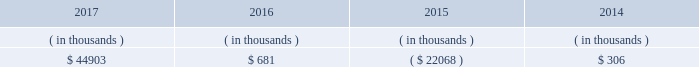All debt and common and preferred stock issuances by entergy texas require prior regulatory approval .
Debt issuances are also subject to issuance tests set forth in its bond indenture and other agreements .
Entergy texas has sufficient capacity under these tests to meet its foreseeable capital needs .
Entergy texas 2019s receivables from or ( payables to ) the money pool were as follows as of december 31 for each of the following years. .
See note 4 to the financial statements for a description of the money pool .
Entergy texas has a credit facility in the amount of $ 150 million scheduled to expire in august 2022 .
The credit facility allows entergy texas to issue letters of credit against $ 30 million of the borrowing capacity of the facility .
As of december 31 , 2017 , there were no cash borrowings and $ 25.6 million of letters of credit outstanding under the credit facility .
In addition , entergy texas is a party to an uncommitted letter of credit facility as a means to post collateral to support its obligations to miso .
As of december 31 , 2017 , a $ 22.8 million letter of credit was outstanding under entergy texas 2019s letter of credit facility .
See note 4 to the financial statements for additional discussion of the credit facilities .
Entergy texas obtained authorizations from the ferc through october 2019 for short-term borrowings , not to exceed an aggregate amount of $ 200 million at any time outstanding , and long-term borrowings and security issuances .
See note 4 to the financial statements for further discussion of entergy texas 2019s short-term borrowing limits .
Entergy texas , inc .
And subsidiaries management 2019s financial discussion and analysis state and local rate regulation and fuel-cost recovery the rates that entergy texas charges for its services significantly influence its financial position , results of operations , and liquidity .
Entergy texas is regulated and the rates charged to its customers are determined in regulatory proceedings .
The puct , a governmental agency , is primarily responsible for approval of the rates charged to customers .
Filings with the puct 2011 rate case in november 2011 , entergy texas filed a rate case requesting a $ 112 million base rate increase reflecting a 10.6% ( 10.6 % ) return on common equity based on an adjusted june 2011 test year . a0 a0the rate case also proposed a purchased power recovery rider . a0 a0on january 12 , 2012 , the puct voted not to address the purchased power recovery rider in the rate case , but the puct voted to set a baseline in the rate case proceeding that would be applicable if a purchased power capacity rider is approved in a separate proceeding . a0 a0in april 2012 the puct staff filed direct testimony recommending a base rate increase of $ 66 million and a 9.6% ( 9.6 % ) return on common equity . a0 a0the puct staff , however , subsequently filed a statement of position in the proceeding indicating that it was still evaluating the position it would ultimately take in the case regarding entergy texas 2019s recovery of purchased power capacity costs and entergy texas 2019s proposal to defer its miso transition expenses . a0 a0in april 2012 , entergy texas filed rebuttal testimony indicating a revised request for a $ 105 million base rate increase . a0 a0a hearing was held in late-april through early-may 2012 .
In september 2012 the puct issued an order approving a $ 28 million rate increase , effective july 2012 . a0 a0the order included a finding that 201ca return on common equity ( roe ) of 9.80 percent will allow [entergy texas] a reasonable opportunity to earn a reasonable return on invested capital . 201d a0 a0the order also provided for increases in depreciation rates and the annual storm reserve accrual . a0 a0the order also reduced entergy texas 2019s proposed purchased power capacity costs , stating that they are not known and measurable ; reduced entergy texas 2019s regulatory assets associated with hurricane rita ; excluded from rate recovery capitalized financially-based incentive compensation ; included $ 1.6 million of miso transition expense in base rates ; and reduced entergy 2019s texas 2019s fuel reconciliation recovery by $ 4 .
If no payables were paid off between 2016 and 2017 , what is the value payables which were added in 2017? 
Computations: (44903 - 681)
Answer: 44222.0. 